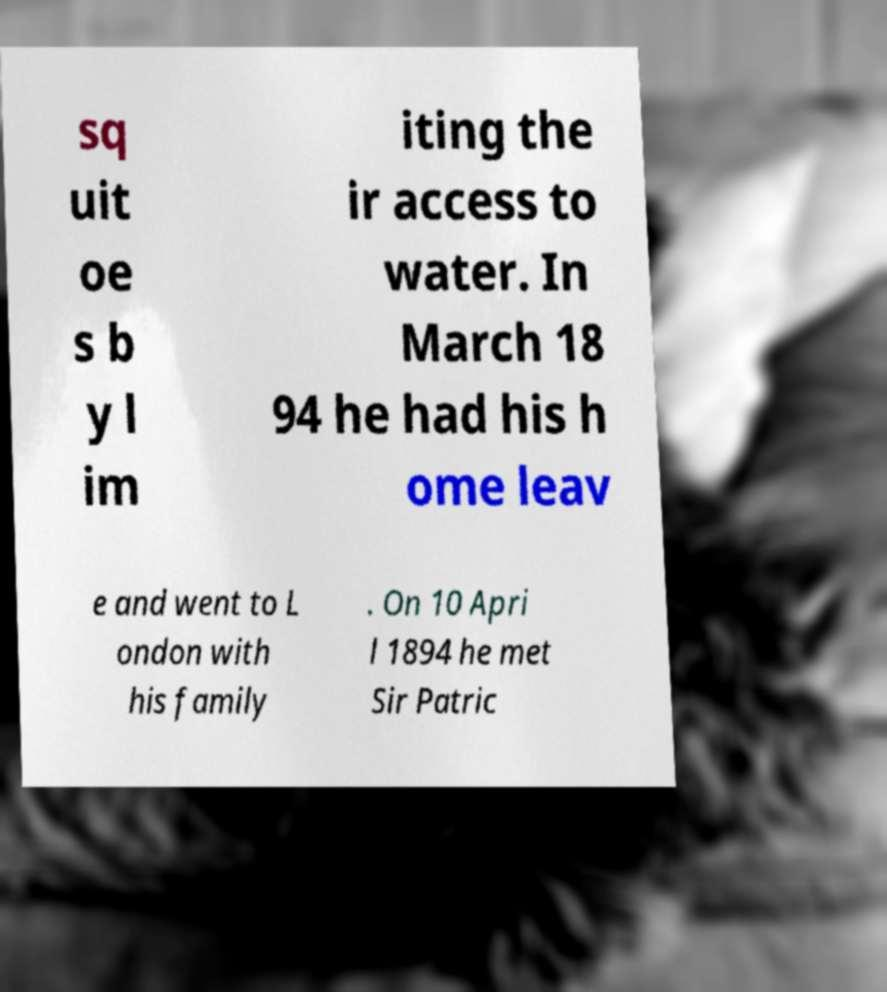I need the written content from this picture converted into text. Can you do that? sq uit oe s b y l im iting the ir access to water. In March 18 94 he had his h ome leav e and went to L ondon with his family . On 10 Apri l 1894 he met Sir Patric 